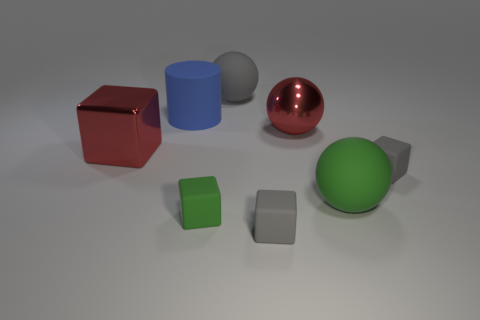Subtract all metal spheres. How many spheres are left? 2 Subtract all green balls. How many gray cubes are left? 2 Subtract all green blocks. How many blocks are left? 3 Subtract all blue spheres. Subtract all red cubes. How many spheres are left? 3 Subtract all cylinders. How many objects are left? 7 Add 1 small green matte blocks. How many objects exist? 9 Subtract all big brown metal spheres. Subtract all red cubes. How many objects are left? 7 Add 8 big cubes. How many big cubes are left? 9 Add 3 blue rubber things. How many blue rubber things exist? 4 Subtract 0 cyan cylinders. How many objects are left? 8 